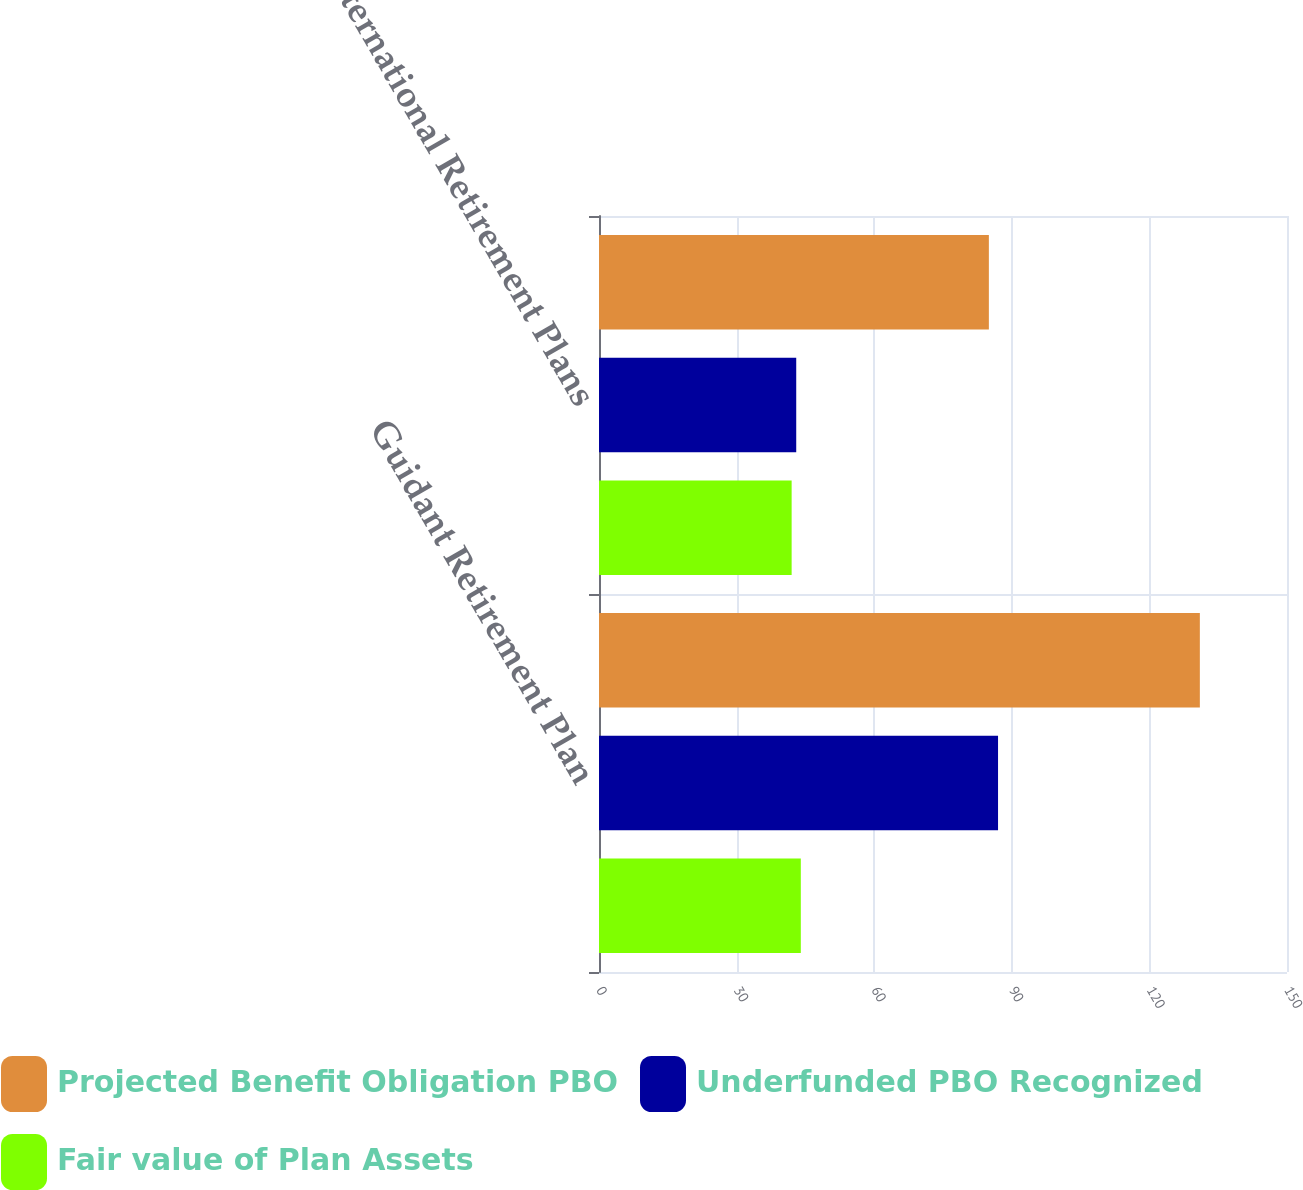<chart> <loc_0><loc_0><loc_500><loc_500><stacked_bar_chart><ecel><fcel>Guidant Retirement Plan<fcel>International Retirement Plans<nl><fcel>Projected Benefit Obligation PBO<fcel>131<fcel>85<nl><fcel>Underfunded PBO Recognized<fcel>87<fcel>43<nl><fcel>Fair value of Plan Assets<fcel>44<fcel>42<nl></chart> 